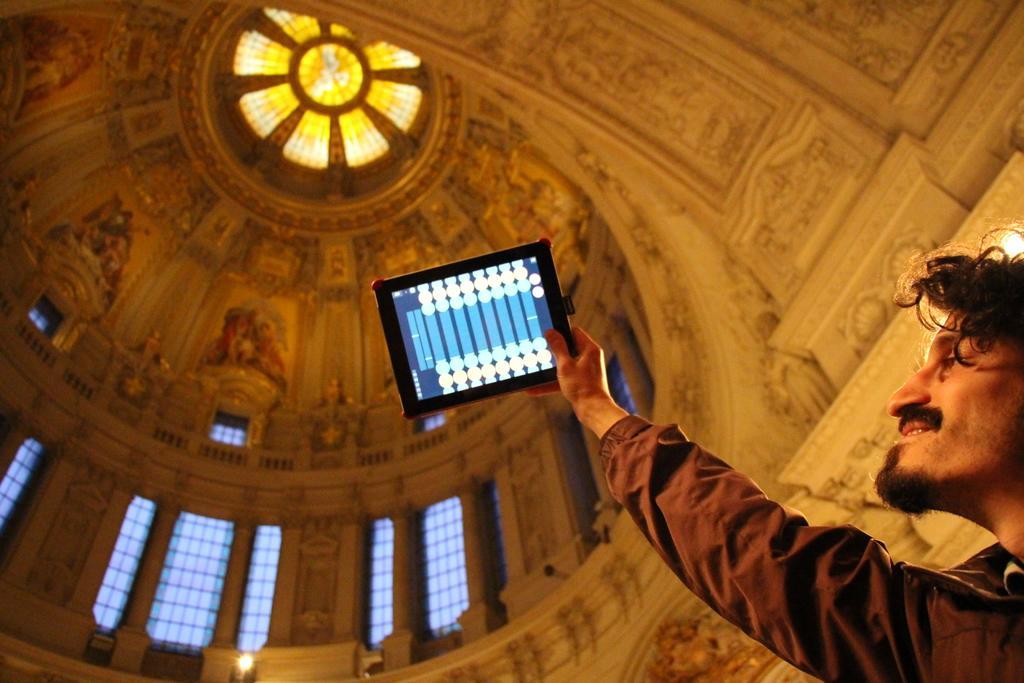How would you summarize this image in a sentence or two? In this picture we can observe a person standing on the right side, holding a tablet in his hand. He is wearing brown color shirt and smiling. In the background we can observe a dome from inside the building. There are some carvings on the wall. 